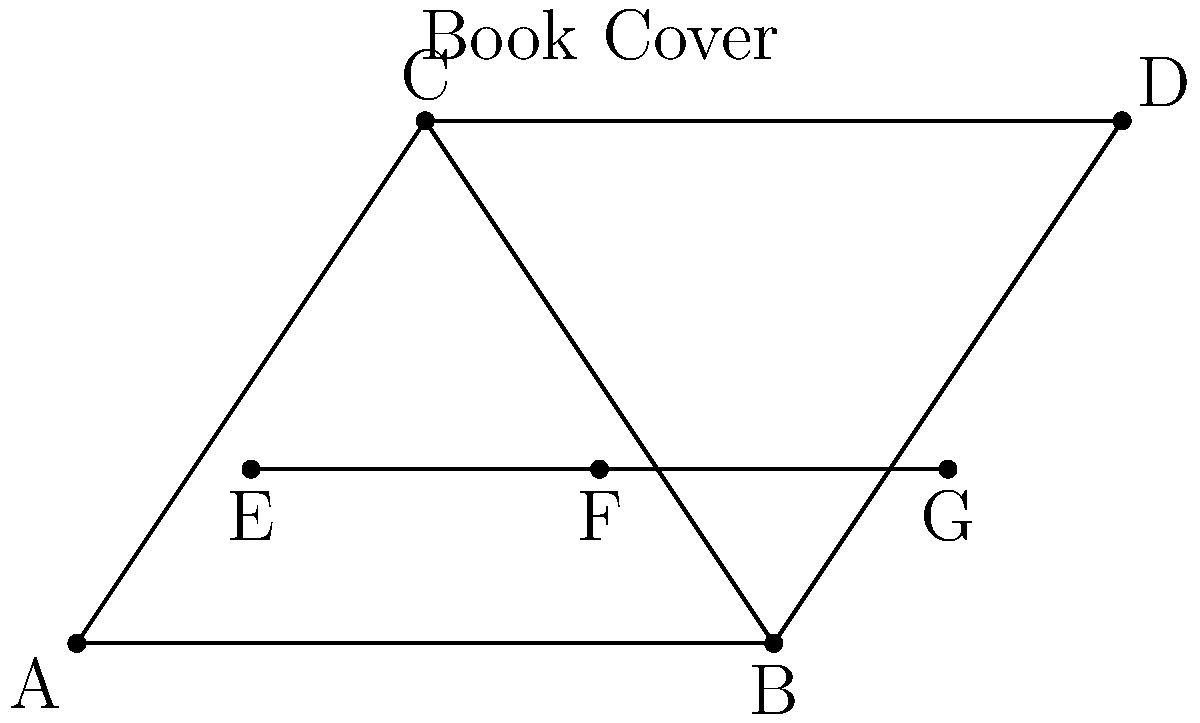In the book cover design shown above, identify the pair of congruent triangles and explain why they are congruent. How might this geometric pattern contribute to the overall aesthetic of the book cover? To identify the congruent triangles and explain their congruence, let's follow these steps:

1. Observe the triangles in the design: We can see triangles ABC, BCD, and EFG.

2. Compare the triangles:
   - Triangle ABC and triangle BCD share the same base BC.
   - The height of both triangles appears to be the same.
   - Triangle EFG is smaller and positioned differently.

3. Apply congruence criteria:
   - Side BC is common to both triangles ABC and BCD.
   - AC and CD appear to be equal in length.
   - Angles BAC and BDC both appear to be right angles.

4. Conclude congruence:
   Based on the Right Angle-Hypotenuse-Side (RHS) congruence criterion, we can conclude that triangles ABC and BCD are congruent.

5. Aesthetic contribution:
   - The congruent triangles create a symmetrical and balanced design.
   - They form a larger triangle shape, which can symbolize stability or growth.
   - The smaller triangle EFG adds visual interest and breaks the symmetry slightly.
   - This geometric pattern might reflect themes of duality, balance, or transformation in the book's content.

As a book club member who appreciates physical copies, you might consider how this design could relate to the book's themes or inspire discussion points during your meetings.
Answer: Triangles ABC and BCD are congruent by the RHS criterion. 